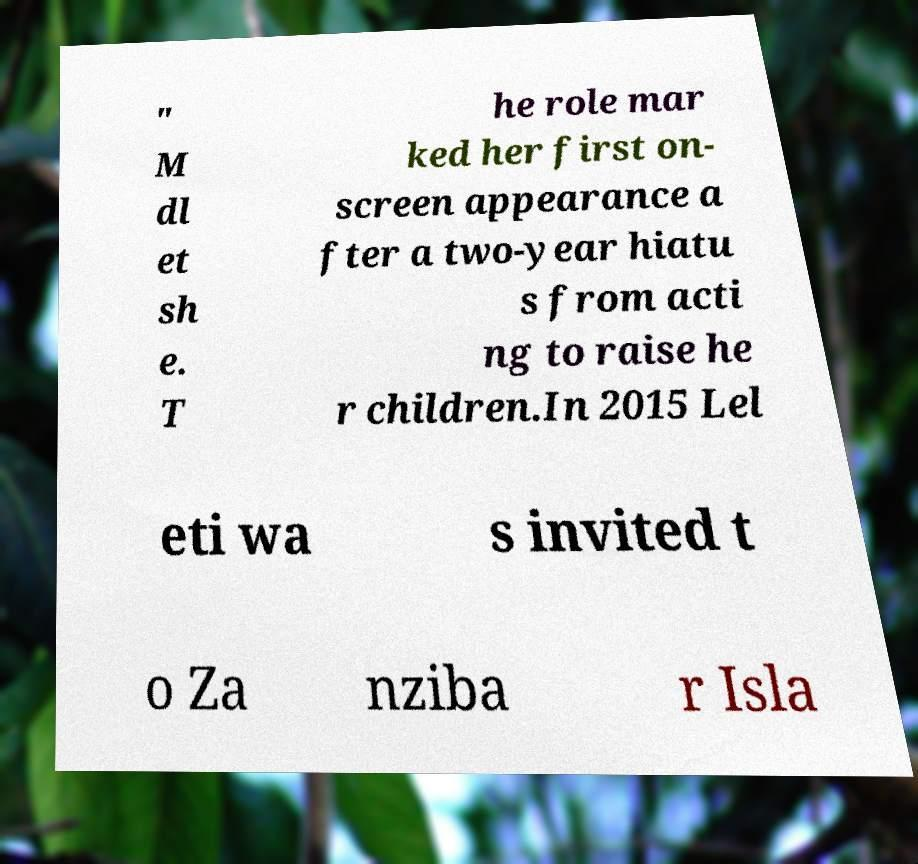Can you read and provide the text displayed in the image?This photo seems to have some interesting text. Can you extract and type it out for me? " M dl et sh e. T he role mar ked her first on- screen appearance a fter a two-year hiatu s from acti ng to raise he r children.In 2015 Lel eti wa s invited t o Za nziba r Isla 